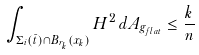<formula> <loc_0><loc_0><loc_500><loc_500>\int _ { \Sigma _ { i } ( \bar { t } ) \cap B _ { r _ { k } } ( x _ { k } ) } H ^ { 2 } \, d A _ { g _ { f l a t } } \leq \frac { k } { n }</formula> 